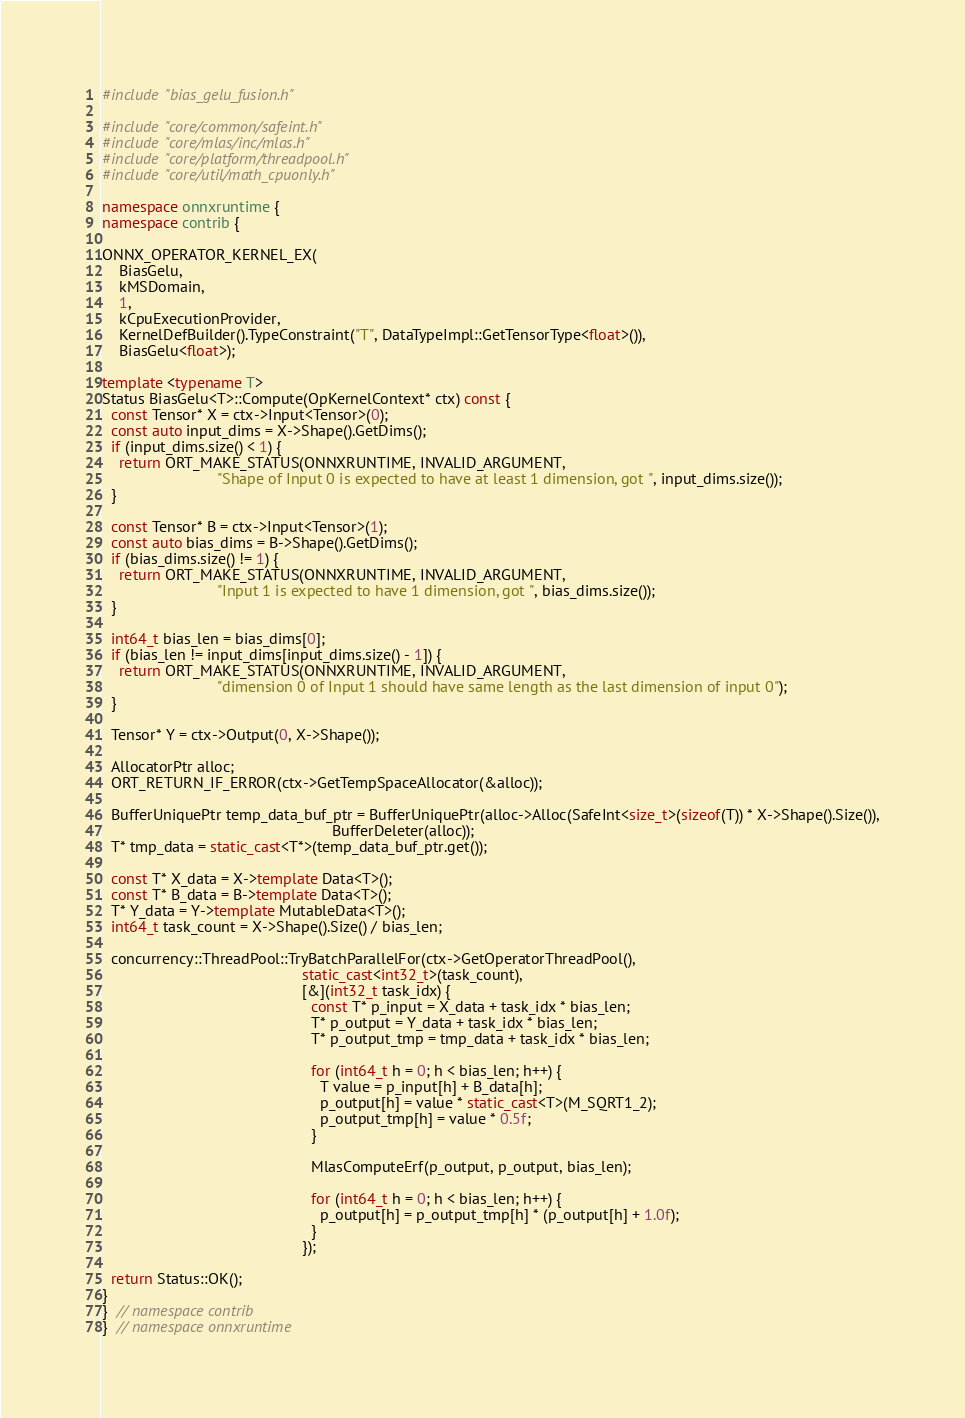<code> <loc_0><loc_0><loc_500><loc_500><_C++_>#include "bias_gelu_fusion.h"

#include "core/common/safeint.h"
#include "core/mlas/inc/mlas.h"
#include "core/platform/threadpool.h"
#include "core/util/math_cpuonly.h"

namespace onnxruntime {
namespace contrib {

ONNX_OPERATOR_KERNEL_EX(
    BiasGelu,
    kMSDomain,
    1,
    kCpuExecutionProvider,
    KernelDefBuilder().TypeConstraint("T", DataTypeImpl::GetTensorType<float>()),
    BiasGelu<float>);

template <typename T>
Status BiasGelu<T>::Compute(OpKernelContext* ctx) const {
  const Tensor* X = ctx->Input<Tensor>(0);
  const auto input_dims = X->Shape().GetDims();
  if (input_dims.size() < 1) {
    return ORT_MAKE_STATUS(ONNXRUNTIME, INVALID_ARGUMENT,
                           "Shape of Input 0 is expected to have at least 1 dimension, got ", input_dims.size());
  }

  const Tensor* B = ctx->Input<Tensor>(1);
  const auto bias_dims = B->Shape().GetDims();
  if (bias_dims.size() != 1) {
    return ORT_MAKE_STATUS(ONNXRUNTIME, INVALID_ARGUMENT,
                           "Input 1 is expected to have 1 dimension, got ", bias_dims.size());
  }

  int64_t bias_len = bias_dims[0];
  if (bias_len != input_dims[input_dims.size() - 1]) {
    return ORT_MAKE_STATUS(ONNXRUNTIME, INVALID_ARGUMENT,
                           "dimension 0 of Input 1 should have same length as the last dimension of input 0");
  }

  Tensor* Y = ctx->Output(0, X->Shape());

  AllocatorPtr alloc;
  ORT_RETURN_IF_ERROR(ctx->GetTempSpaceAllocator(&alloc));

  BufferUniquePtr temp_data_buf_ptr = BufferUniquePtr(alloc->Alloc(SafeInt<size_t>(sizeof(T)) * X->Shape().Size()),
                                                      BufferDeleter(alloc));
  T* tmp_data = static_cast<T*>(temp_data_buf_ptr.get());

  const T* X_data = X->template Data<T>();
  const T* B_data = B->template Data<T>();
  T* Y_data = Y->template MutableData<T>();
  int64_t task_count = X->Shape().Size() / bias_len;

  concurrency::ThreadPool::TryBatchParallelFor(ctx->GetOperatorThreadPool(),
                                               static_cast<int32_t>(task_count),
                                               [&](int32_t task_idx) {
                                                 const T* p_input = X_data + task_idx * bias_len;
                                                 T* p_output = Y_data + task_idx * bias_len;
                                                 T* p_output_tmp = tmp_data + task_idx * bias_len;

                                                 for (int64_t h = 0; h < bias_len; h++) {
                                                   T value = p_input[h] + B_data[h];
                                                   p_output[h] = value * static_cast<T>(M_SQRT1_2);
                                                   p_output_tmp[h] = value * 0.5f;
                                                 }

                                                 MlasComputeErf(p_output, p_output, bias_len);

                                                 for (int64_t h = 0; h < bias_len; h++) {
                                                   p_output[h] = p_output_tmp[h] * (p_output[h] + 1.0f);
                                                 }
                                               });

  return Status::OK();
}
}  // namespace contrib
}  // namespace onnxruntime
</code> 